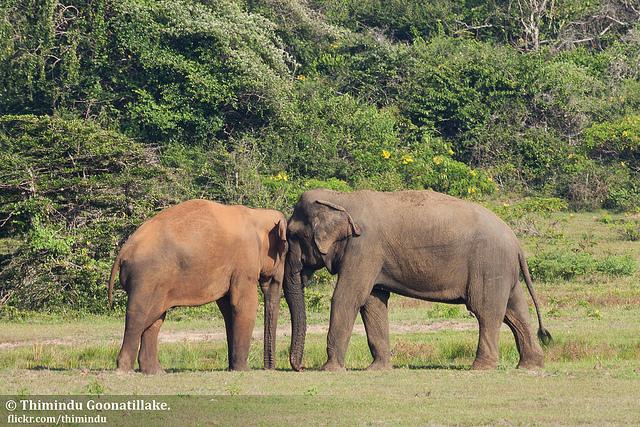Are the tails of the two elephants the same length?
Keep it brief. No. Does animal appear to have thick skin?
Answer briefly. Yes. What is the elephant doing?
Quick response, please. Standing. Are these animals facing each other?
Concise answer only. Yes. 